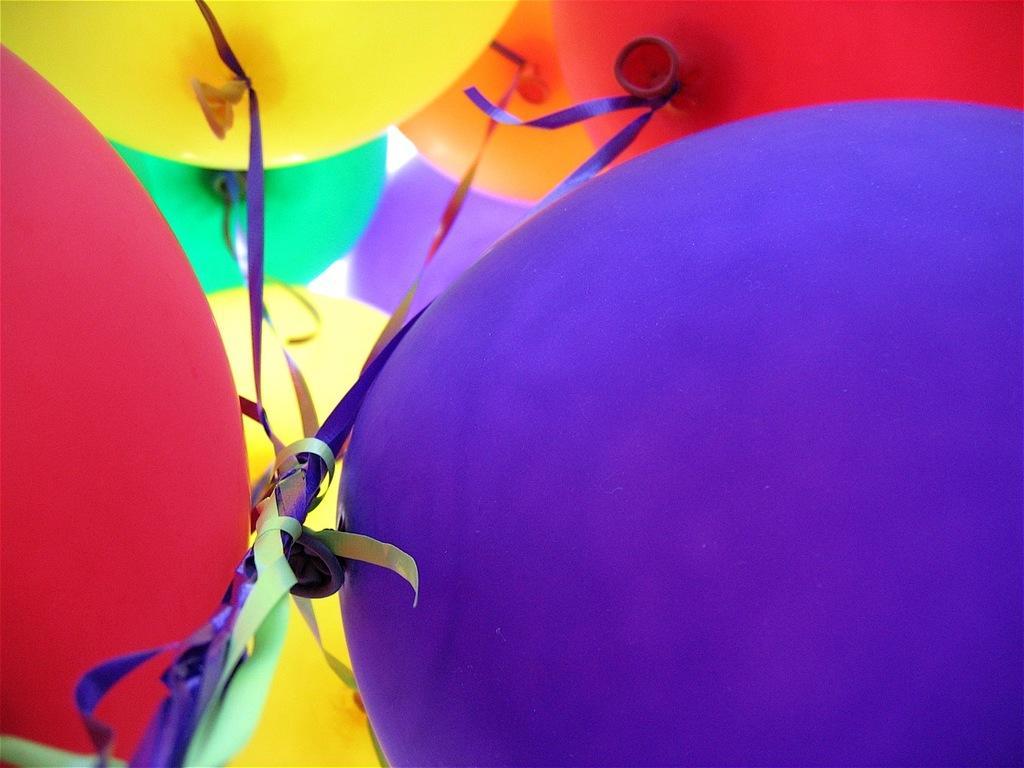Can you describe this image briefly? In this picture we can see different color of balloons which are of red, yellow, green, orange and a blue one. We can also see these all balloons are tied together. 